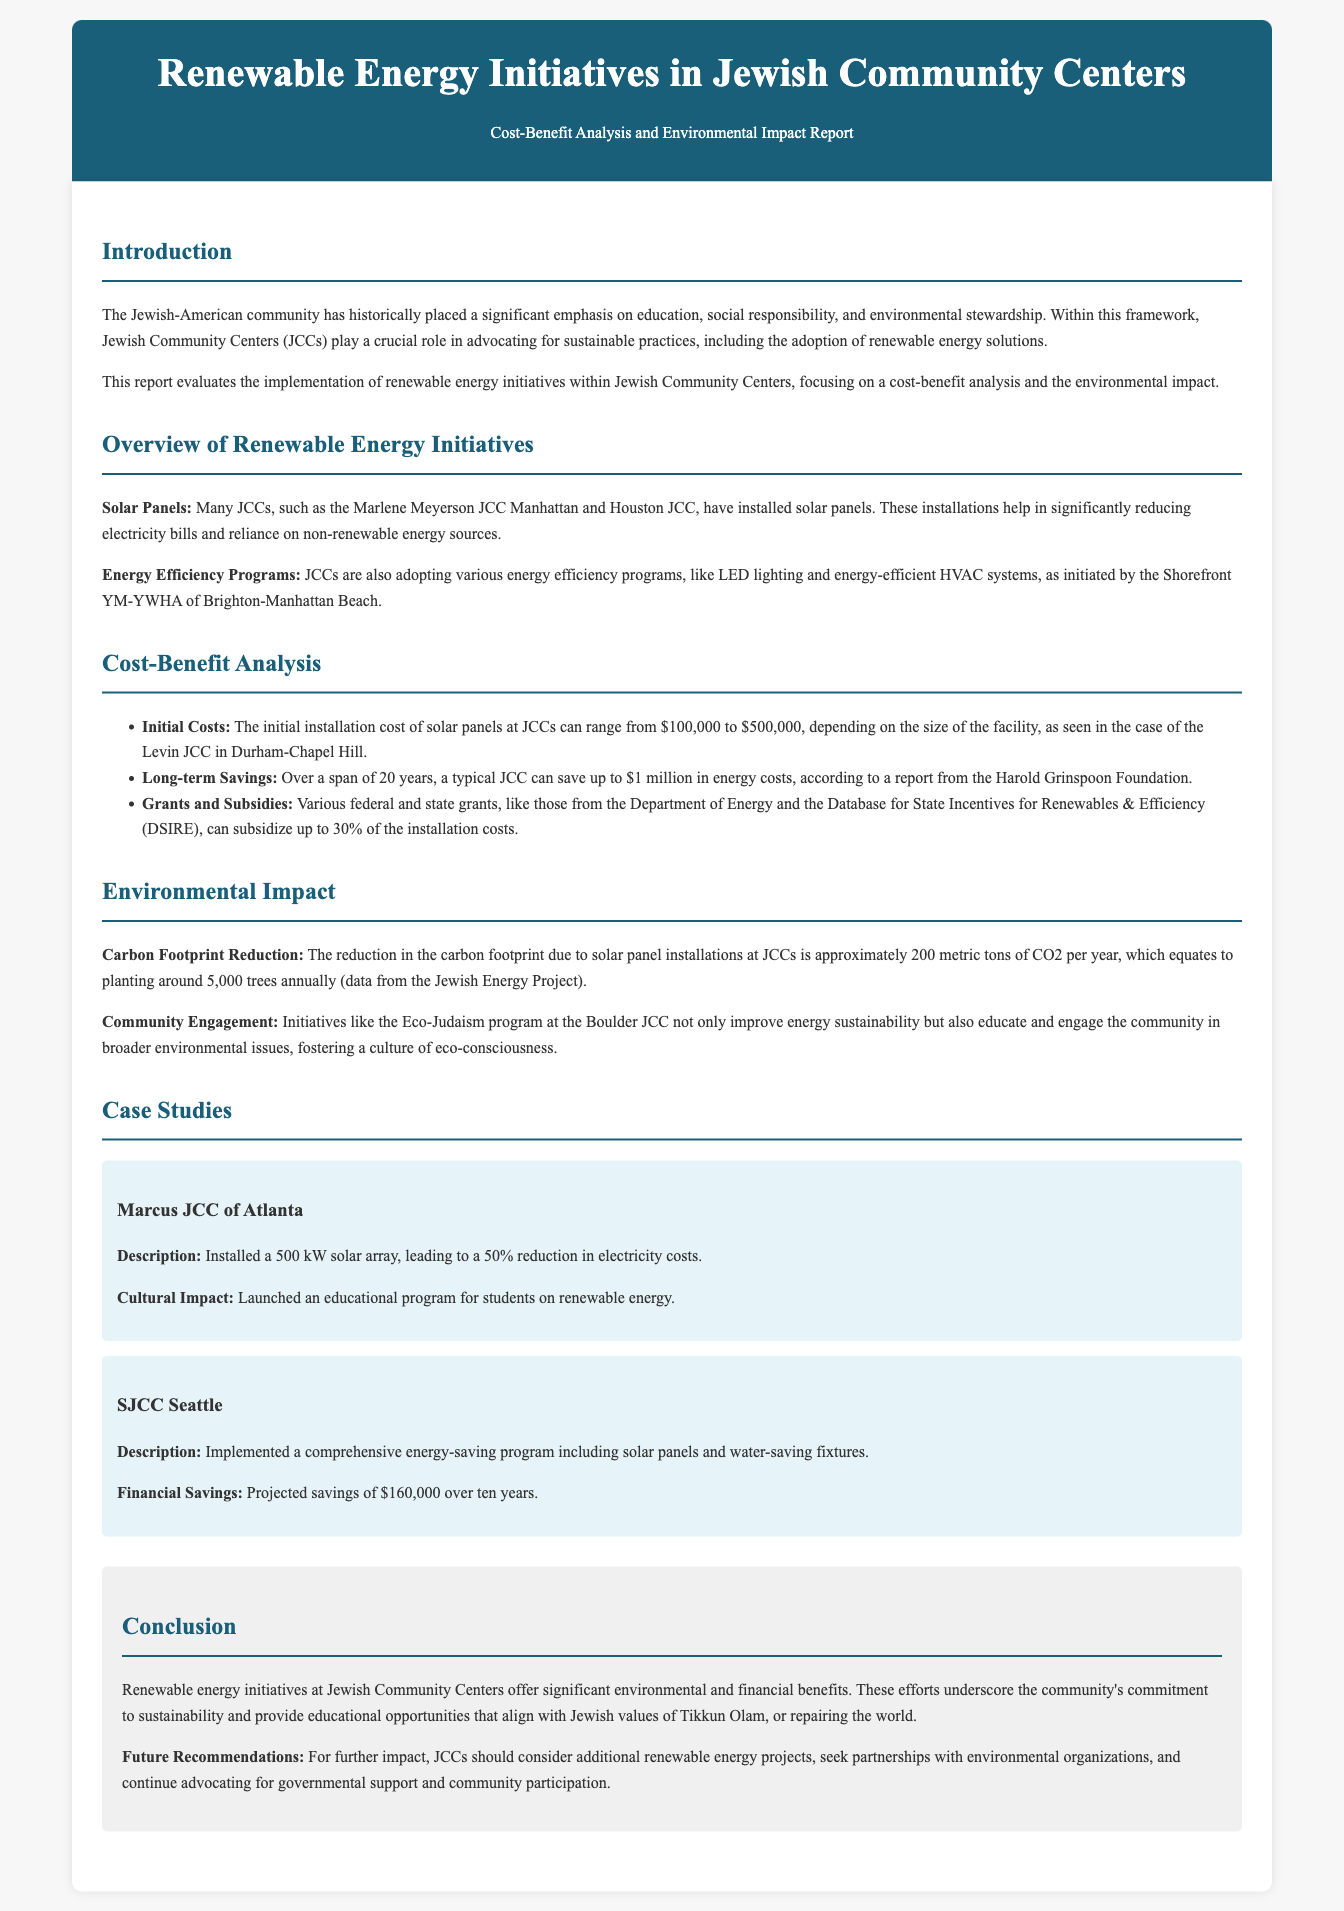what is the primary focus of the report? The report evaluates the implementation of renewable energy initiatives within Jewish Community Centers, focusing on cost-benefit analysis and environmental impact.
Answer: renewable energy initiatives how much can a typical JCC save on energy costs over 20 years? According to the report, over a span of 20 years, a typical JCC can save up to $1 million in energy costs.
Answer: $1 million which JCC installed a 500 kW solar array? The Marcus JCC of Atlanta installed a 500 kW solar array, leading to a reduction in electricity costs.
Answer: Marcus JCC of Atlanta what is the annual reduction in CO2 emissions due to solar panel installations? The reduction in the carbon footprint due to solar panel installations at JCCs is approximately 200 metric tons of CO2 per year.
Answer: 200 metric tons what is the purpose of the Eco-Judaism program mentioned? The Eco-Judaism program at the Boulder JCC improves energy sustainability and educates the community about broader environmental issues.
Answer: education and engagement what is the initial installation cost range for solar panels at JCCs? The initial installation cost of solar panels at JCCs can range from $100,000 to $500,000.
Answer: $100,000 to $500,000 how much can grants and subsidies subsidize of the installation costs? Various federal and state grants can subsidize up to 30% of the installation costs.
Answer: 30% what Jewish value does the report associate with renewable energy initiatives? The report associates renewable energy initiatives with the Jewish value of Tikkun Olam, or repairing the world.
Answer: Tikkun Olam 